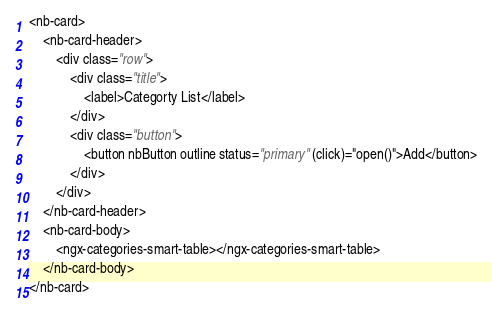<code> <loc_0><loc_0><loc_500><loc_500><_HTML_><nb-card>
    <nb-card-header>
        <div class="row">
            <div class="title">
                <label>Categorty List</label>
            </div>
            <div class="button">
                <button nbButton outline status="primary" (click)="open()">Add</button>
            </div>
        </div>
    </nb-card-header>
    <nb-card-body>
        <ngx-categories-smart-table></ngx-categories-smart-table>
    </nb-card-body>
</nb-card>

</code> 